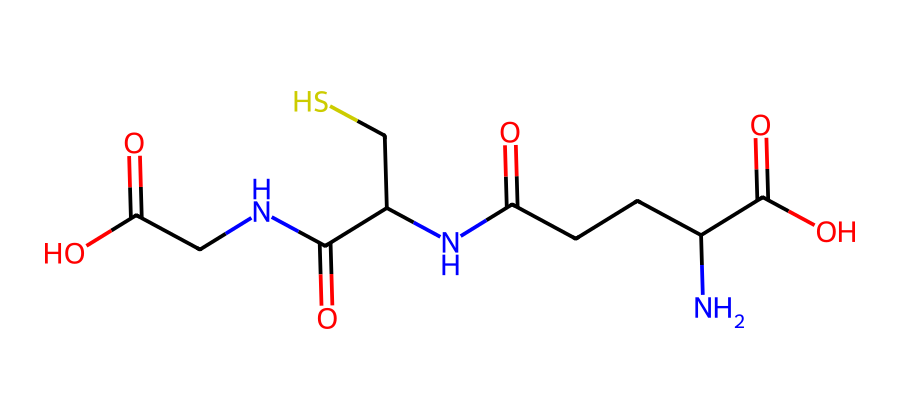What is the molecular formula of glutathione? To find the molecular formula, one needs to count the number of each type of atom present in the SMILES representation. By analyzing the structure, we see the presence of Carbon (C), Hydrogen (H), Nitrogen (N), Oxygen (O), and Sulfur (S) atoms, resulting in the formula C10H17N3O6S.
Answer: C10H17N3O6S How many sulfur atoms are in glutathione? In the provided SMILES representation, we identify a single sulfur atom (S). Counting the occurrences in the structure confirms there is one sulfur atom present.
Answer: 1 What functional groups are present in glutathione? The SMILES indicates multiple functional groups, including amides (due to the -C(=O)N- groups) and a carboxylic acid (-C(=O)O) as well as a thiol (due to -C(S) in the structure). Identifying these groups from the structural components leads to these conclusions.
Answer: amide, carboxylic acid, thiol How many nitrogen atoms are in glutathione? Upon evaluating the SMILES notation, we quantify the nitrogen atoms, which can be seen in -N- sections of the structure. A closer look shows that there are three nitrogen atoms in total.
Answer: 3 What type of chemical is glutathione considered? Given the presence of functional groups, particularly the thiol group, glutathione is categorized as a tripeptide and antioxidant, as it plays a crucial role in protecting against oxidative stress in biological systems.
Answer: tripeptide, antioxidant How many oxygen atoms are present in glutathione? By examining the molecule's structure in the SMILES representation, we find five oxygen atoms embedded in the various functional groups, particularly in the amides and carboxylic acids. Thus, the tally reveals five oxygen atoms.
Answer: 5 